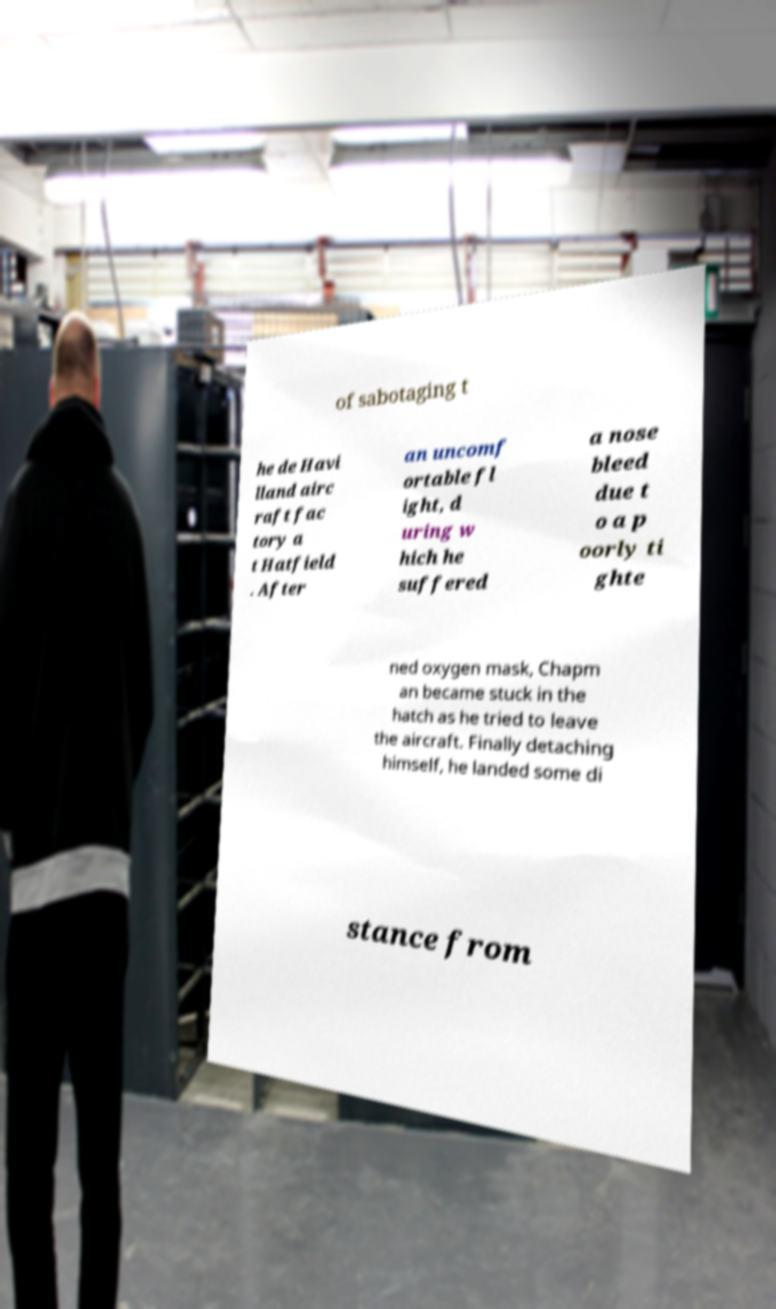What messages or text are displayed in this image? I need them in a readable, typed format. of sabotaging t he de Havi lland airc raft fac tory a t Hatfield . After an uncomf ortable fl ight, d uring w hich he suffered a nose bleed due t o a p oorly ti ghte ned oxygen mask, Chapm an became stuck in the hatch as he tried to leave the aircraft. Finally detaching himself, he landed some di stance from 